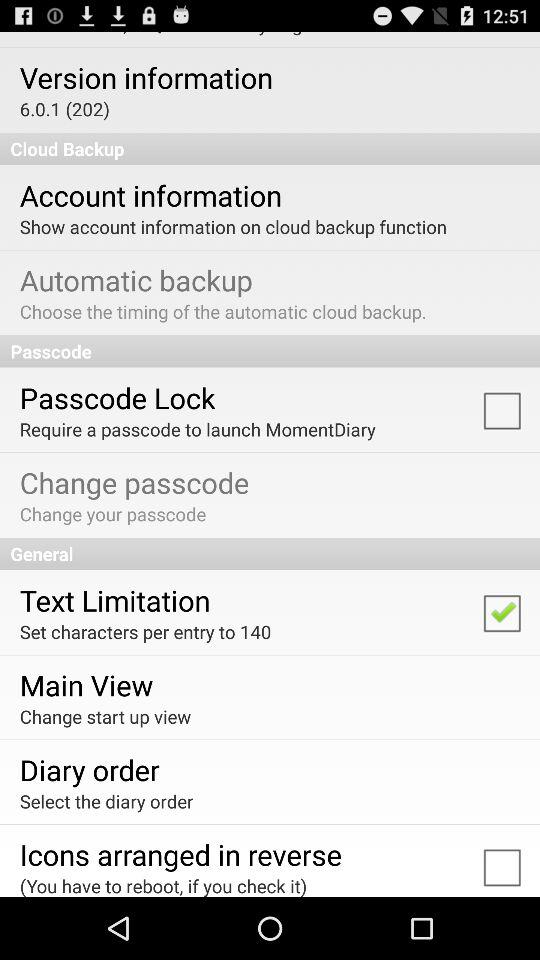What is the version of the application? The version of the application is 6.0.1 (202). 